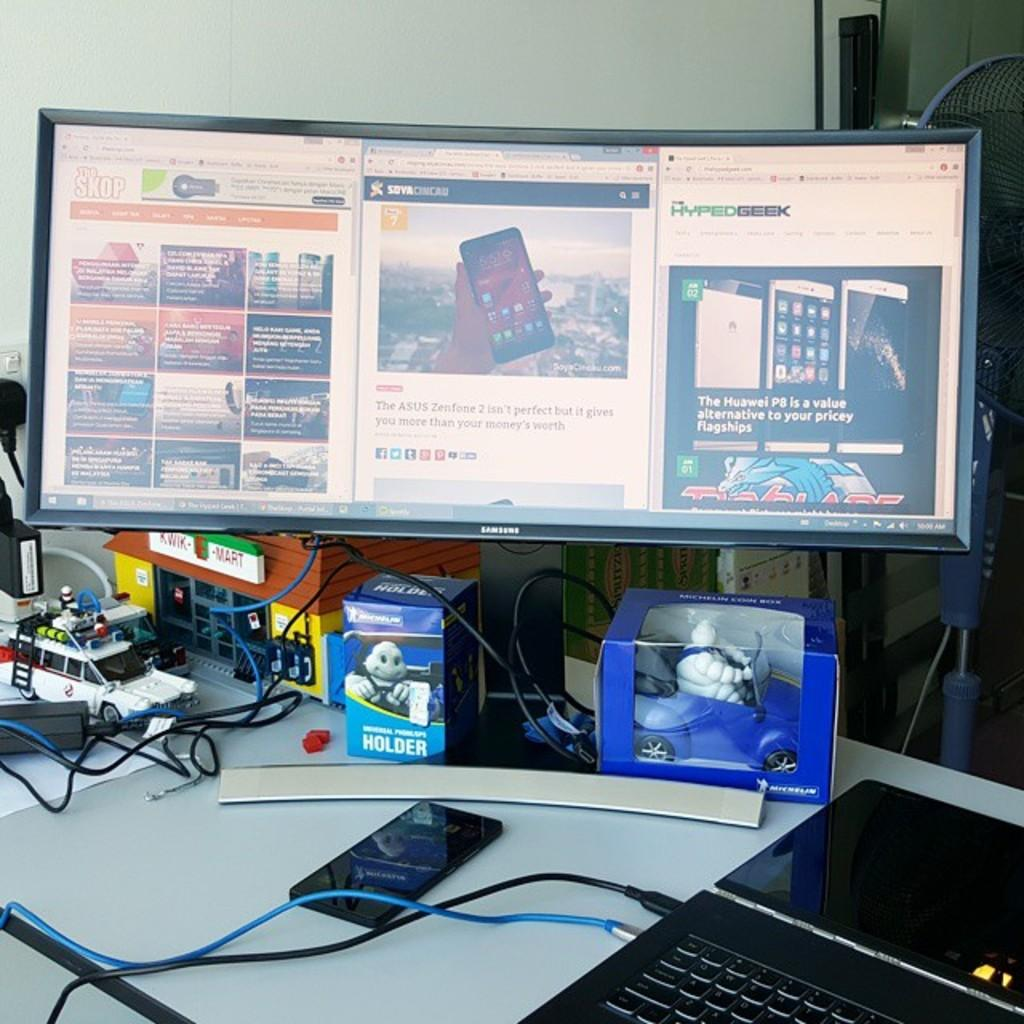Provide a one-sentence caption for the provided image. A black samsung monitor displays some phones on it. 